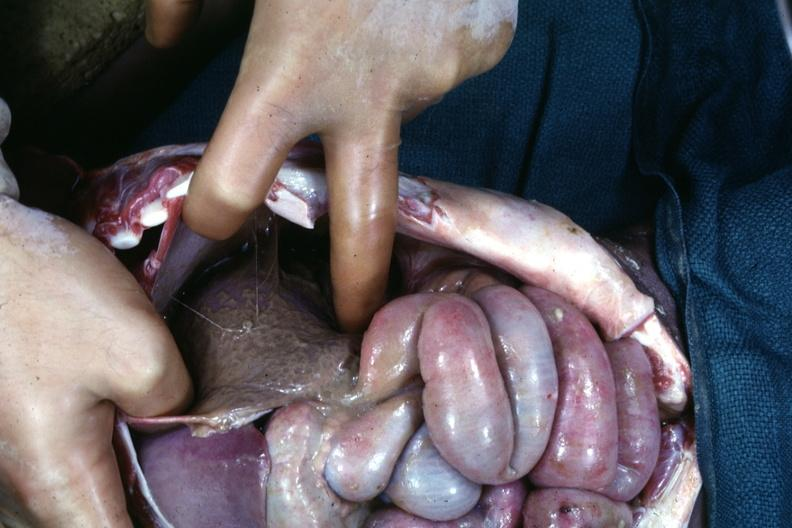does an opened peritoneal cavity cause by fibrous band strangulation see other slides?
Answer the question using a single word or phrase. Yes 